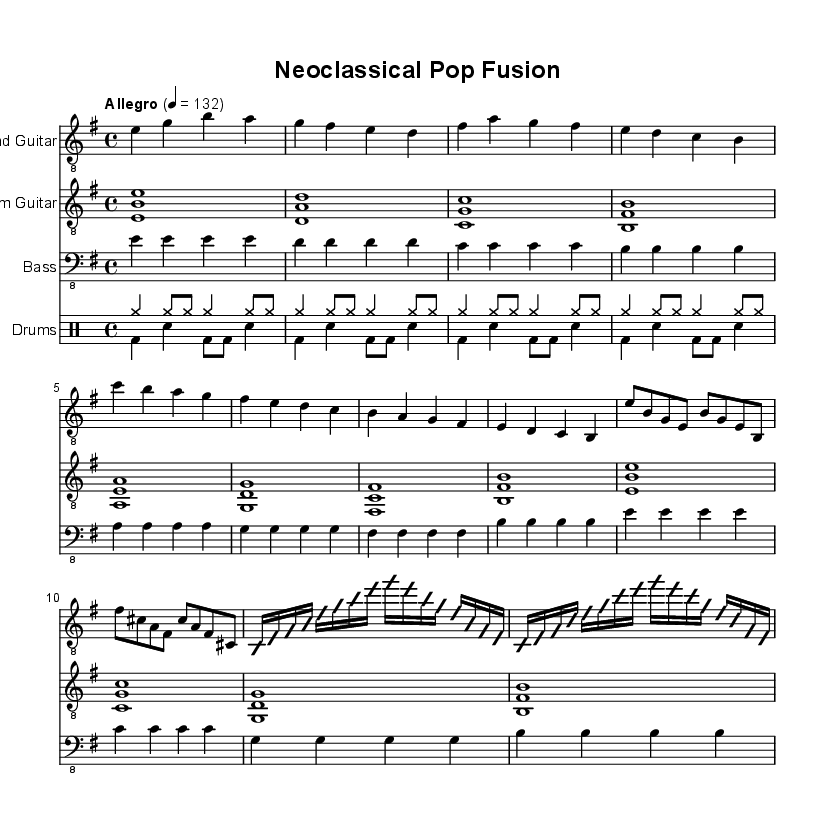What is the key signature of this music? The key signature is determined by the sharp or flat symbols at the beginning of the staff, indicating the tonal center. Here, there are no sharps or flats noted, which indicates that it is in E minor.
Answer: E minor What is the time signature of this sheet music? The time signature is found at the beginning of the staff, following the key signature. It indicates how many beats are in each measure. The "4/4" shows that there are four beats per measure, which is a common time signature in pop music.
Answer: 4/4 What is the marked tempo of this piece? The tempo is indicated by the text "Allegro" and a metronome marking of 4 = 132. "Allegro" suggests a fast pace, and the number indicates the beats per minute.
Answer: 132 How many measures are in the Verse section? The number of measures can be counted in the line that is labeled as the Verse, which has four measures as indicated by the repetitions of the bar lines within that segment.
Answer: 4 What roles do the electric guitar and rhythm guitar play in this piece? The electric guitar is primarily responsible for melody and intricate solos, while the rhythm guitar supports the harmony and provides a rhythmic foundation as indicated by the different notes and patterns played by each instrument throughout the sections.
Answer: Melody and harmony Which section contains the guitar solo and how is it presented? The guitar solo is located in the "Guitar Solo" section, which is visually distinguished by the use of the "improvisationOn" and "improvisationOff" commands, indicating free playing over defined changes and the use of 16th notes for a quick, intricate sequence.
Answer: Guitar Solo How does the bass line interact with the chord progressions throughout the piece? The bass line corresponds to the root notes of the chords played in the other instruments, and it follows a simple quarter note pattern that supports the harmonic structure. By aligning with the chord changes, it creates a solid foundation while allowing the melody and rhythm to stand out.
Answer: Supports harmony 